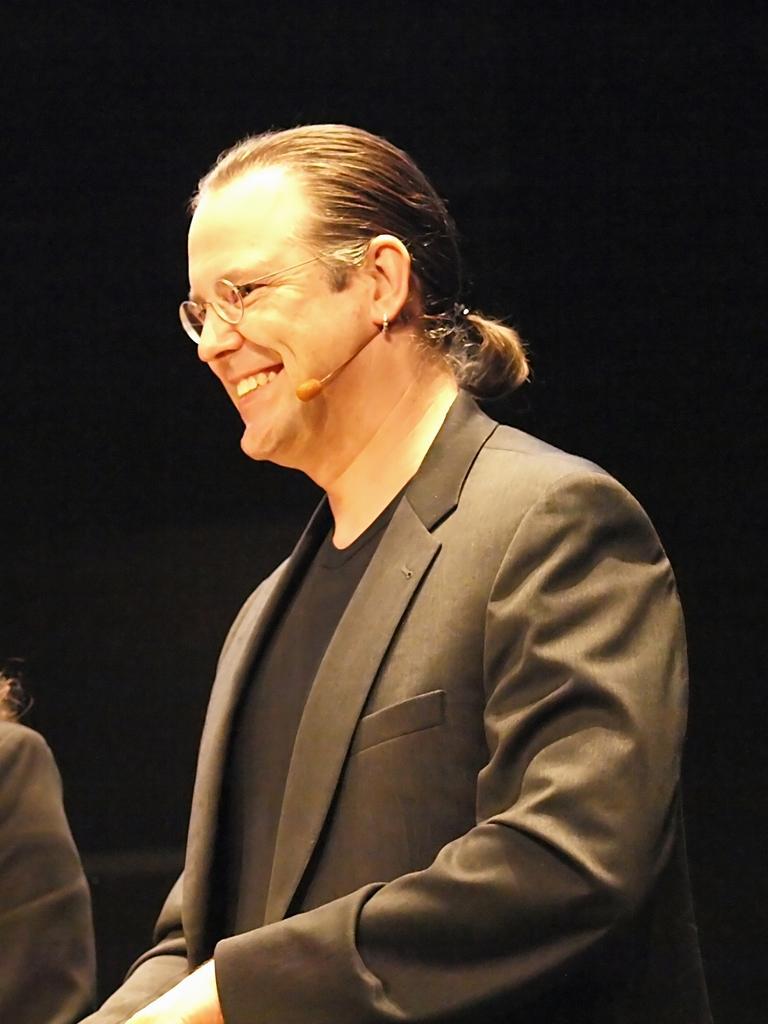Describe this image in one or two sentences. In this picture I can see a man in front, who is wearing a suit and I see that he is smiling and I see a mic near to his mouth. In the background I see a person near to him and I see that it is dark. 